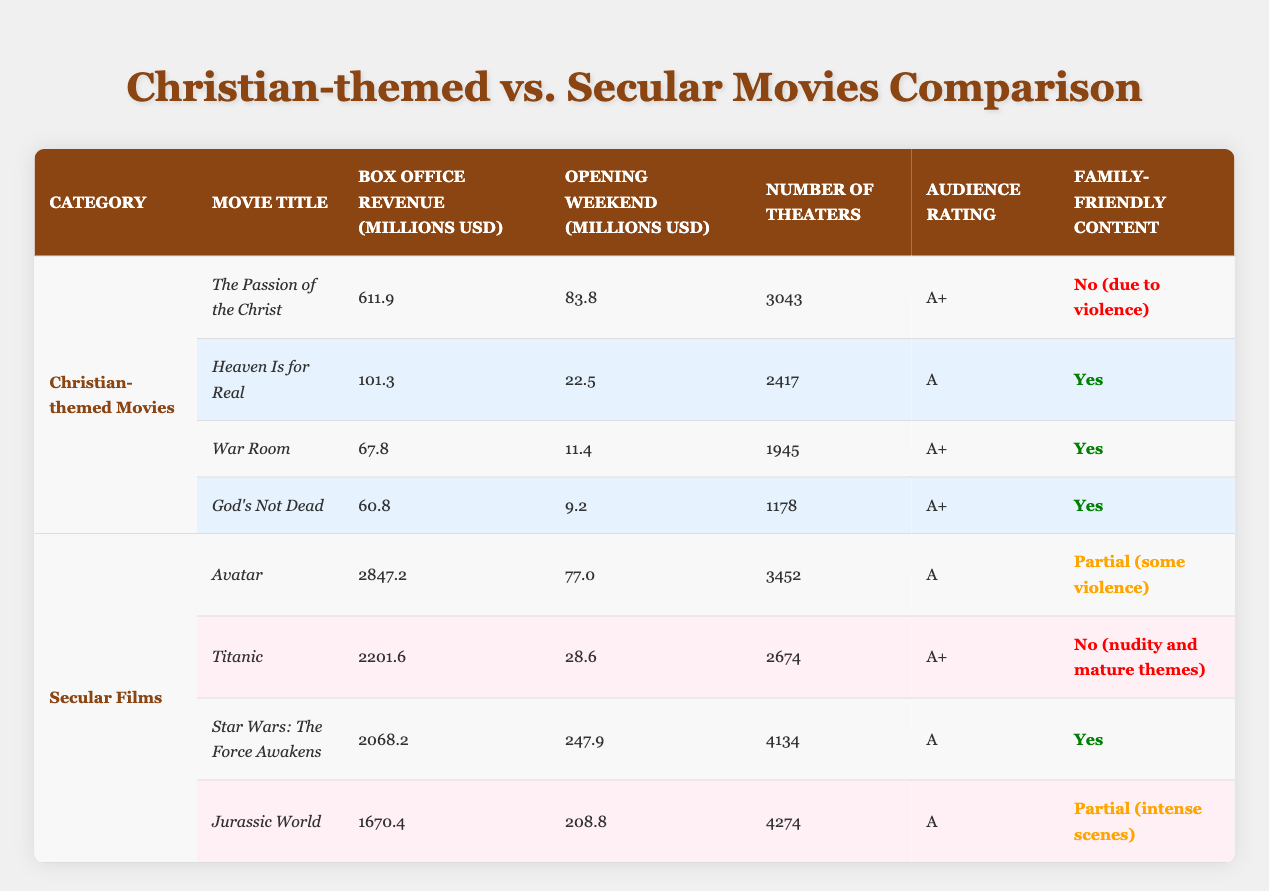What is the box office revenue for "The Passion of the Christ"? The box office revenue for "The Passion of the Christ" is listed directly in the table as 611.9 million USD.
Answer: 611.9 million USD Which secular film had the highest opening weekend revenue? From the table, "Star Wars: The Force Awakens" had the highest opening weekend revenue at 247.9 million USD, compared to the other secular films.
Answer: Star Wars: The Force Awakens How many theaters did "God's Not Dead" show in? The table indicates that "God's Not Dead" was shown in 1178 theaters.
Answer: 1178 theaters What is the average box office revenue of the Christian-themed movies listed? To find the average box office revenue, add the revenues of the Christian-themed movies: 611.9 + 101.3 + 67.8 + 60.8 = 841.8 million USD. There are 4 movies, so the average is 841.8 / 4 = 210.45 million USD.
Answer: 210.45 million USD Is "Heaven Is for Real" considered family-friendly? Yes, according to the table, "Heaven Is for Real" is marked as family-friendly ("Yes").
Answer: Yes Which type of films had a greater total box office revenue, Christian-themed or secular films? The total box office revenue for Christian-themed films is 841.8 million USD (calculated previously). The total for secular films is 2847.2 + 2201.6 + 2068.2 + 1670.4 = 10787.4 million USD. Since 10787.4 million USD is greater than 841.8 million USD, secular films had greater revenue.
Answer: Secular films How many Christian-themed movies are rated A+? "The Passion of the Christ," "War Room," and "God's Not Dead" are rated A+. That totals to 3 movies.
Answer: 3 movies Which secular movie is family-friendly, and what is its audience rating? The table shows "Star Wars: The Force Awakens" is family-friendly and has an audience rating of A.
Answer: Star Wars: The Force Awakens, A What percentage of Christian-themed movies are rated A or higher? There are 4 Christian-themed movies listed, and all of them are rated A or higher (A+ or A). Therefore, the percentage is (4/4) * 100 = 100%.
Answer: 100% 